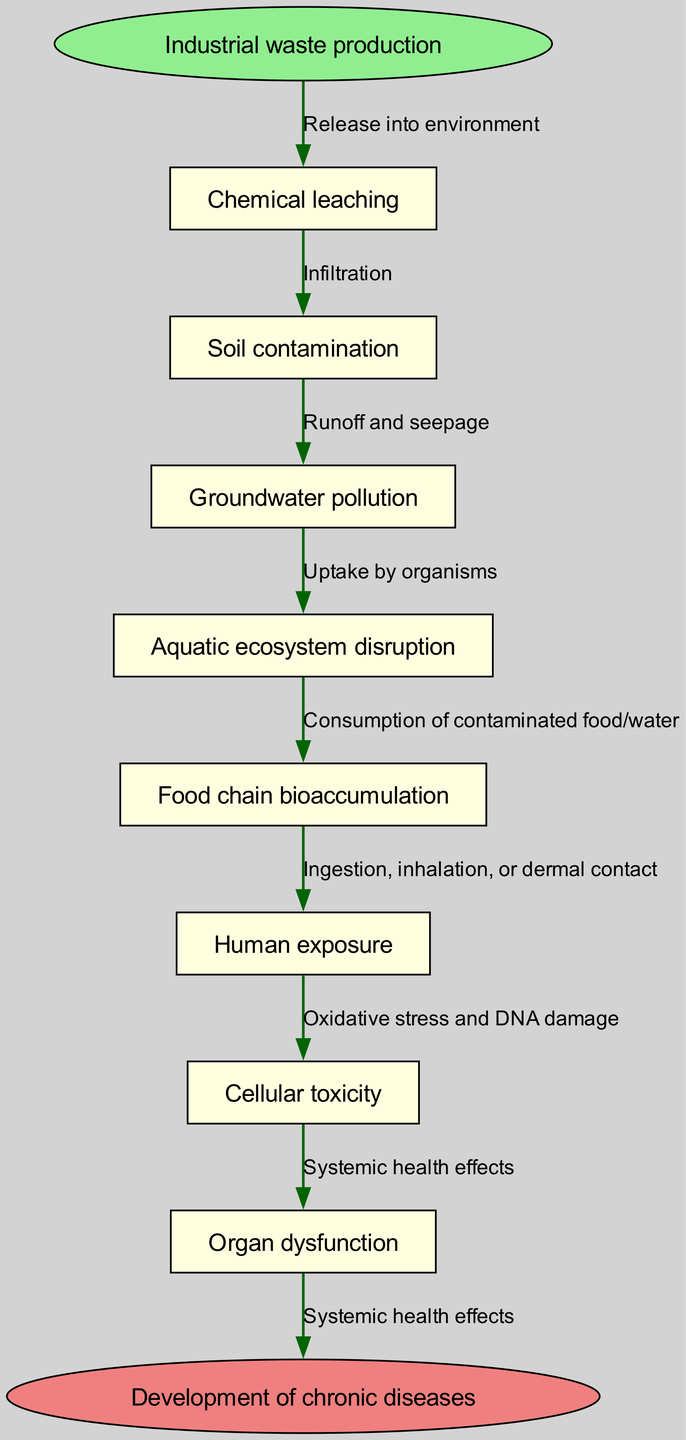What is the start point of the pathway? The start point of the pathway is indicated by the first node in the diagram, which is labeled "Industrial waste production."
Answer: Industrial waste production How many nodes are in the diagram? By counting the distinct nodes listed in the diagram, including the start and end points, there are a total of 8 nodes.
Answer: 8 What chemical process leads to soil contamination? The arrow leading from "Chemical leaching" to "Soil contamination" indicates that chemical leaching causes soil contamination.
Answer: Chemical leaching Which node follows groundwater pollution? Looking at the flow of the diagram, the node that directly follows "Groundwater pollution" is "Aquatic ecosystem disruption."
Answer: Aquatic ecosystem disruption What is the final outcome of the pathway? The end of the flow chart specifies that the final outcome of the pathway is "Development of chronic diseases."
Answer: Development of chronic diseases What type of exposure manifests after human exposure? The next node after "Human exposure" is "Cellular toxicity," indicating that this is the type of health effect that arises.
Answer: Cellular toxicity What are the systemic health effects preceded by? The diagram shows that "Systemic health effects" follows "Oxidative stress and DNA damage," demonstrating that they precede the systemic effects.
Answer: Oxidative stress and DNA damage What is the relationship between food chain bioaccumulation and human exposure? The relationship is indicated by the edge that shows "Consumption of contaminated food/water" as the pathway from "Food chain bioaccumulation" to "Human exposure."
Answer: Consumption of contaminated food/water Which node is directly connected to cellular toxicity? By examining the diagram, we can see that "Organ dysfunction" is directly connected to "Cellular toxicity," indicating its follow-up effect.
Answer: Organ dysfunction 